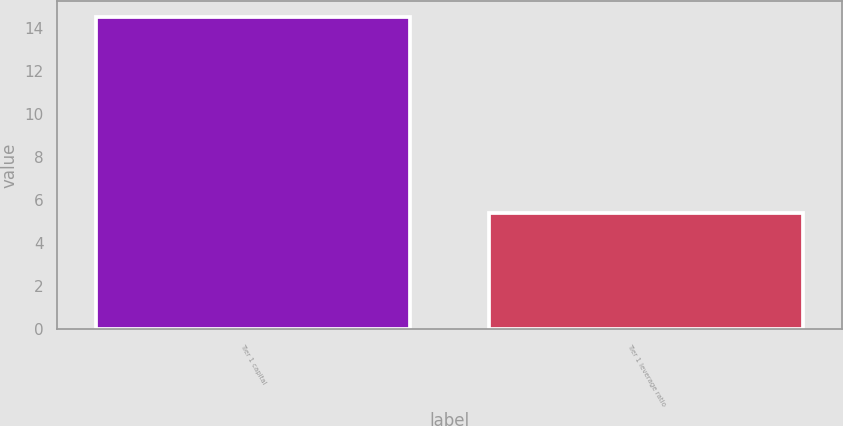Convert chart to OTSL. <chart><loc_0><loc_0><loc_500><loc_500><bar_chart><fcel>Tier 1 capital<fcel>Tier 1 leverage ratio<nl><fcel>14.5<fcel>5.4<nl></chart> 